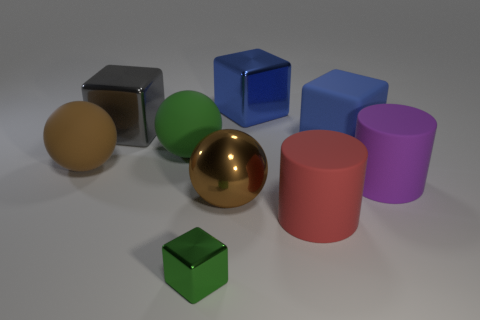How many objects in the image are spherical? There are two spherical objects visible in the image. One is a highly reflective gold-colored sphere, and the other is a matte-finish sphere with a hue that looks like tan or light brown. Could you describe the layout of these spherical objects relative to the green cube? Certainly! The reflective gold-colored sphere is positioned near the center of the image, slightly to the left and behind the green cube from our perspective. The matte tan sphere is located further to the right of the green cube and is a bit farther away compared to the gold sphere. 